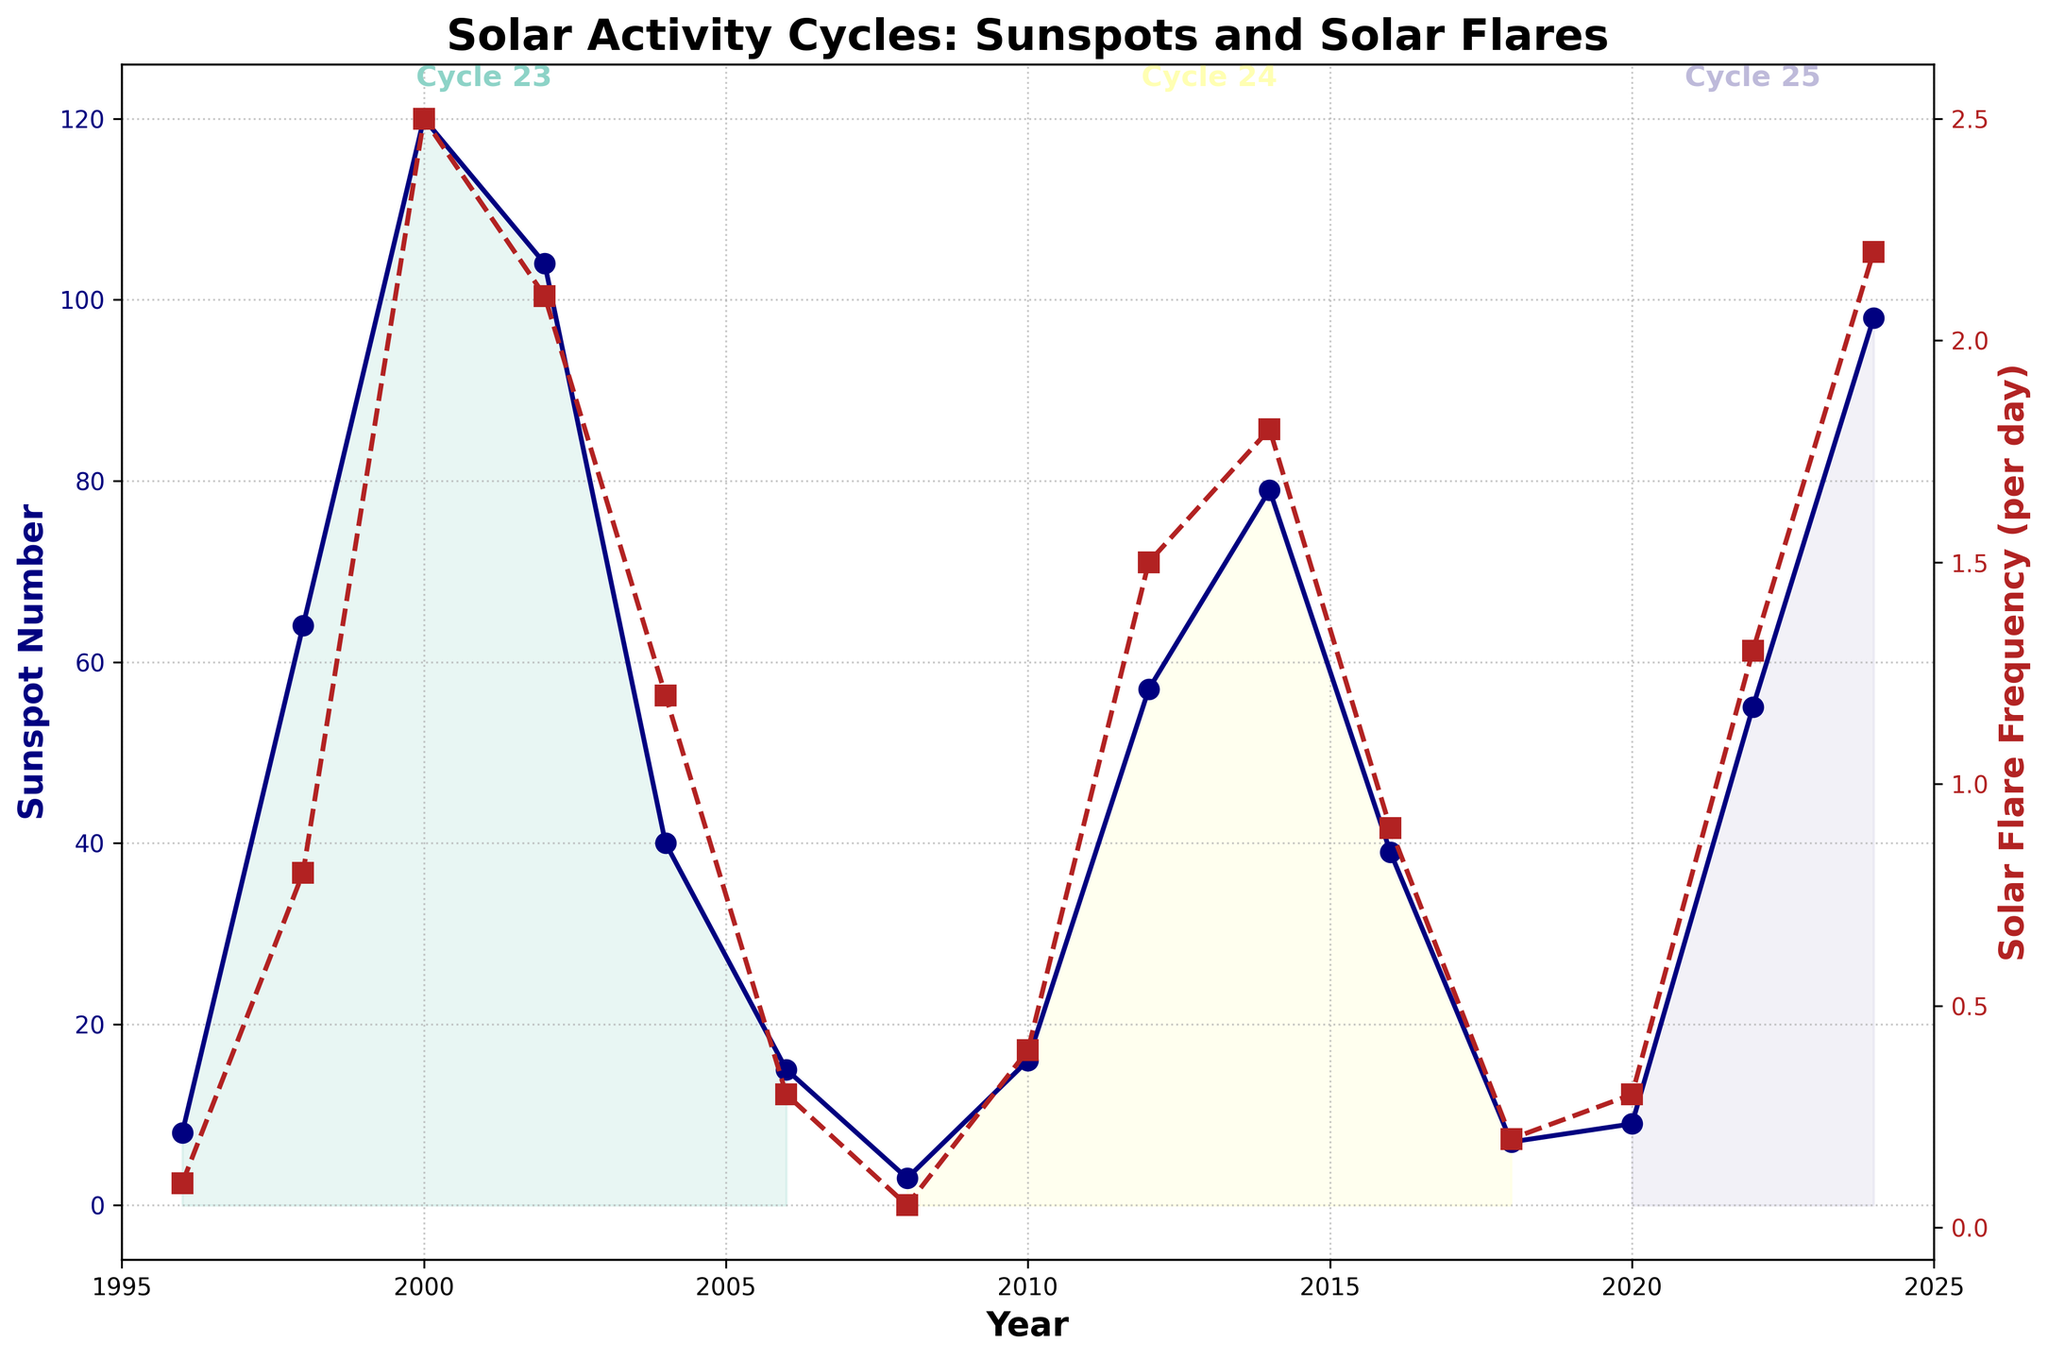What is the highest Sunspot Number recorded in the given years? The highest Sunspot Number is showed by the point with the tallest peak for this series. It occurs in the year 2000, where Sunspot Number is 120
Answer: 120 What Solar Cycle had the highest frequency of Solar Flares? Reviewing the plotted data, Solar Cycle 23 has the highest number of Solar Flares, which peaks in the year 2000, with a frequency of 2.5 flares per day
Answer: Solar Cycle 23 Compare the Sunspot Number in the year 2000 and 2022. Which year had a higher value? In 2000, the Sunspot Number is 120, whereas in 2022, it is 55. So, the year 2000 had a higher Sunspot Number
Answer: 2000 What trend can be observed in Solar Flare Frequency from 2014 to 2018? The Solar Flare Frequency in 2014 is 1.8 and decreases steadily to 0.2 by 2018, indicating a downward trend over these years
Answer: Downward trend Which Solar Cycle had the lowest average Sunspot Number? To find the lowest average Sunspot Number, calculate the average for each cycle. For Cycle 23, the average is (8 + 64 + 120 + 104 + 40 + 15) / 6 = 58.5. For Cycle 24, it's (3 + 16 + 57 + 79 + 39 + 7) / 6 ≈ 33.5. For Cycle 25, it's (9 + 55 + 98) / 3 ≈ 54. So, Solar Cycle 24 had the lowest average
Answer: Cycle 24 What is the average Solar Flare Frequency for Cycle 24? Cycle 24 had frequencies 0.05, 0.4, 1.5, 1.8, 0.9, and 0.2. Adding these gives 4.85. Dividing by 6 (number of data points) results in an average frequency of 4.85/6 ≈ 0.81
Answer: 0.81 In which years did the Sunspot Number drop below 10? Sunspot Number drops below 10 in these years: 1996 (8), 2008 (3), 2018 (7), and 2020 (9)
Answer: 1996, 2008, 2018, 2020 How does Solar Flare Frequency in 2022 compare to 2004? Solar Flare Frequency in 2022 is 1.3, while in 2004 is 1.2. Thus, it is slightly higher in 2022
Answer: Higher in 2022 